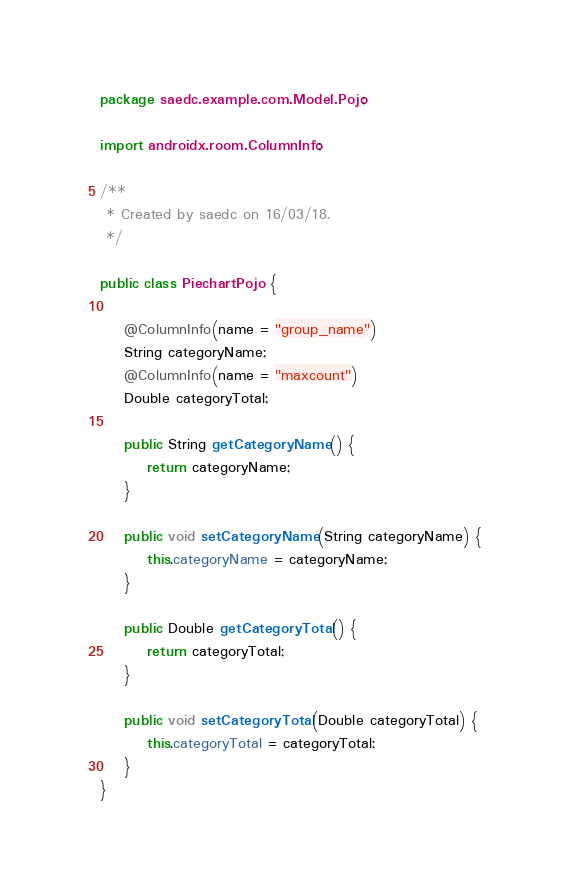<code> <loc_0><loc_0><loc_500><loc_500><_Java_>package saedc.example.com.Model.Pojo;

import androidx.room.ColumnInfo;

/**
 * Created by saedc on 16/03/18.
 */

public class PiechartPojo {

    @ColumnInfo(name = "group_name")
    String categoryName;
    @ColumnInfo(name = "maxcount")
    Double categoryTotal;

    public String getCategoryName() {
        return categoryName;
    }

    public void setCategoryName(String categoryName) {
        this.categoryName = categoryName;
    }

    public Double getCategoryTotal() {
        return categoryTotal;
    }

    public void setCategoryTotal(Double categoryTotal) {
        this.categoryTotal = categoryTotal;
    }
}
</code> 